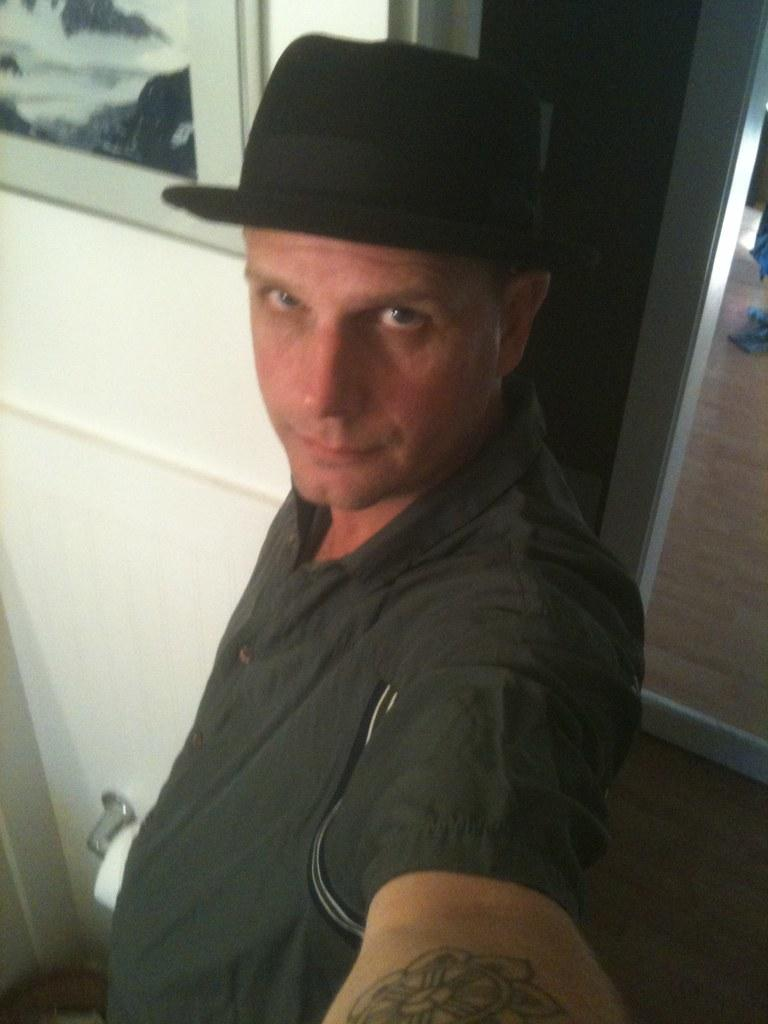Who is present in the image? There is a man in the image. What is the man wearing on his head? The man is wearing a black hat. What can be seen on the left side of the image? There is a frame on the wall on the left side of the image. What is on the right side of the image? There is a door on the right side of the image. What type of coat is the man wearing in the image? The man is not wearing a coat in the image. --- Facts: 1. There is a car in the image. 2. The car is red. 3. There is a person standing next to the car. 4. The person is holding a phone. 5. There is a tree in the background. Absurd Topics: elephant, piano Conversation: What is the main subject in the image? There is a car in the image. What color is the car? The car is red. Who or what is standing next to the car? There is a person standing next to the car. What is the person holding? The person is holding a phone. What can be seen in the background of the image? There is a tree in the background. Reasoning: Let's think step by step in order to continue the user text directly without *any* additional interjections. We start by identifying the main subject of the image, which is the car. Next, we describe specific features of the car, such as the color, which is red. Then, we observe the actions of the person in the image, noting that they are holding a phone. Finally, we describe the background of the image, which includes a tree. Absurd Question/Answer: Can you hear the elephant playing the piano in the image? There is no elephant or piano present in the image. 